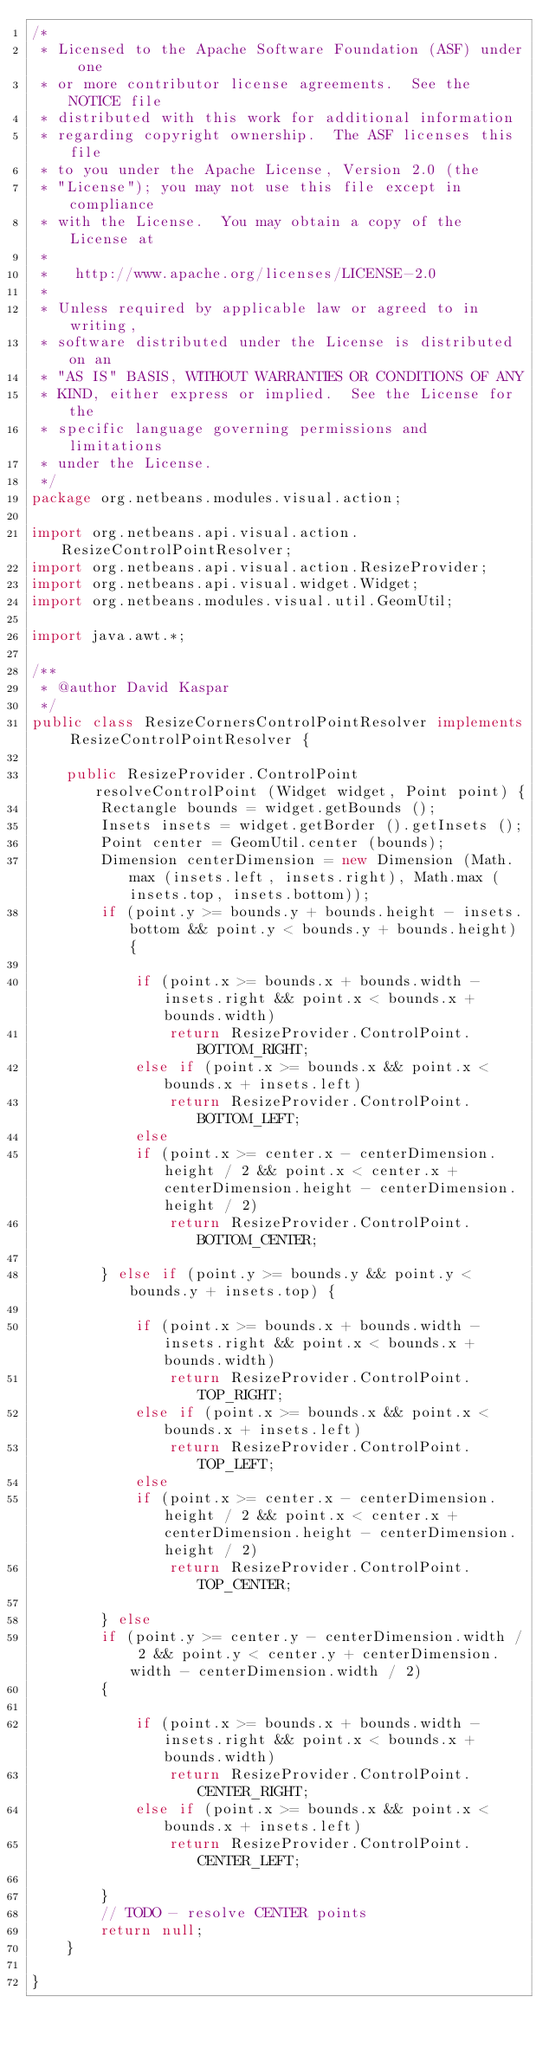Convert code to text. <code><loc_0><loc_0><loc_500><loc_500><_Java_>/*
 * Licensed to the Apache Software Foundation (ASF) under one
 * or more contributor license agreements.  See the NOTICE file
 * distributed with this work for additional information
 * regarding copyright ownership.  The ASF licenses this file
 * to you under the Apache License, Version 2.0 (the
 * "License"); you may not use this file except in compliance
 * with the License.  You may obtain a copy of the License at
 *
 *   http://www.apache.org/licenses/LICENSE-2.0
 *
 * Unless required by applicable law or agreed to in writing,
 * software distributed under the License is distributed on an
 * "AS IS" BASIS, WITHOUT WARRANTIES OR CONDITIONS OF ANY
 * KIND, either express or implied.  See the License for the
 * specific language governing permissions and limitations
 * under the License.
 */
package org.netbeans.modules.visual.action;

import org.netbeans.api.visual.action.ResizeControlPointResolver;
import org.netbeans.api.visual.action.ResizeProvider;
import org.netbeans.api.visual.widget.Widget;
import org.netbeans.modules.visual.util.GeomUtil;

import java.awt.*;

/**
 * @author David Kaspar
 */
public class ResizeCornersControlPointResolver implements ResizeControlPointResolver {

    public ResizeProvider.ControlPoint resolveControlPoint (Widget widget, Point point) {
        Rectangle bounds = widget.getBounds ();
        Insets insets = widget.getBorder ().getInsets ();
        Point center = GeomUtil.center (bounds);
        Dimension centerDimension = new Dimension (Math.max (insets.left, insets.right), Math.max (insets.top, insets.bottom));
        if (point.y >= bounds.y + bounds.height - insets.bottom && point.y < bounds.y + bounds.height) {

            if (point.x >= bounds.x + bounds.width - insets.right && point.x < bounds.x + bounds.width)
                return ResizeProvider.ControlPoint.BOTTOM_RIGHT;
            else if (point.x >= bounds.x && point.x < bounds.x + insets.left)
                return ResizeProvider.ControlPoint.BOTTOM_LEFT;
            else
            if (point.x >= center.x - centerDimension.height / 2 && point.x < center.x + centerDimension.height - centerDimension.height / 2)
                return ResizeProvider.ControlPoint.BOTTOM_CENTER;

        } else if (point.y >= bounds.y && point.y < bounds.y + insets.top) {

            if (point.x >= bounds.x + bounds.width - insets.right && point.x < bounds.x + bounds.width)
                return ResizeProvider.ControlPoint.TOP_RIGHT;
            else if (point.x >= bounds.x && point.x < bounds.x + insets.left)
                return ResizeProvider.ControlPoint.TOP_LEFT;
            else
            if (point.x >= center.x - centerDimension.height / 2 && point.x < center.x + centerDimension.height - centerDimension.height / 2)
                return ResizeProvider.ControlPoint.TOP_CENTER;

        } else
        if (point.y >= center.y - centerDimension.width / 2 && point.y < center.y + centerDimension.width - centerDimension.width / 2)
        {

            if (point.x >= bounds.x + bounds.width - insets.right && point.x < bounds.x + bounds.width)
                return ResizeProvider.ControlPoint.CENTER_RIGHT;
            else if (point.x >= bounds.x && point.x < bounds.x + insets.left)
                return ResizeProvider.ControlPoint.CENTER_LEFT;

        }
        // TODO - resolve CENTER points
        return null;
    }

}
</code> 